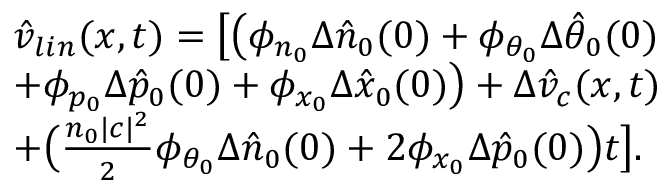<formula> <loc_0><loc_0><loc_500><loc_500>\begin{array} { r l } & { \hat { v } _ { l i n } ( x , t ) = \left [ \left ( \phi _ { n _ { 0 } } \Delta \hat { n } _ { 0 } ( 0 ) + \phi _ { \theta _ { 0 } } \Delta \hat { \theta } _ { 0 } ( 0 ) } \\ & { + \phi _ { p _ { 0 } } \Delta \hat { p } _ { 0 } ( 0 ) + \phi _ { x _ { 0 } } \Delta \hat { x } _ { 0 } ( 0 ) \right ) + \Delta \hat { v } _ { c } ( x , t ) } \\ & { + \left ( \frac { n _ { 0 } | c | ^ { 2 } } { 2 } \phi _ { \theta _ { 0 } } \Delta \hat { n } _ { 0 } ( 0 ) + 2 \phi _ { x _ { 0 } } \Delta \hat { p } _ { 0 } ( 0 ) \right ) t \right ] . } \end{array}</formula> 